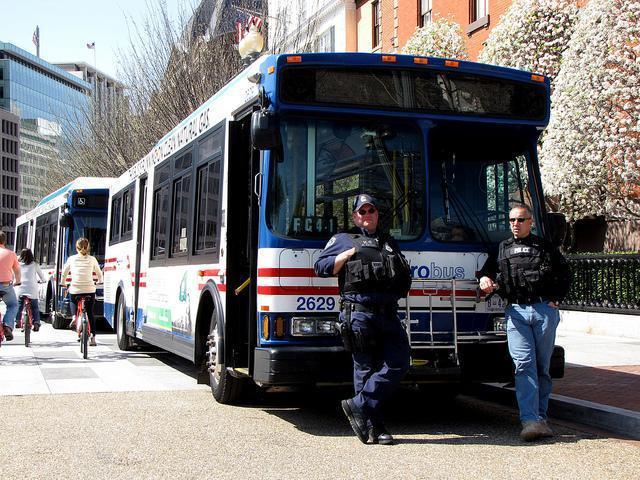How many people are riding bikes?
Give a very brief answer. 3. How many buses are in the picture?
Give a very brief answer. 2. How many people are there?
Give a very brief answer. 3. 